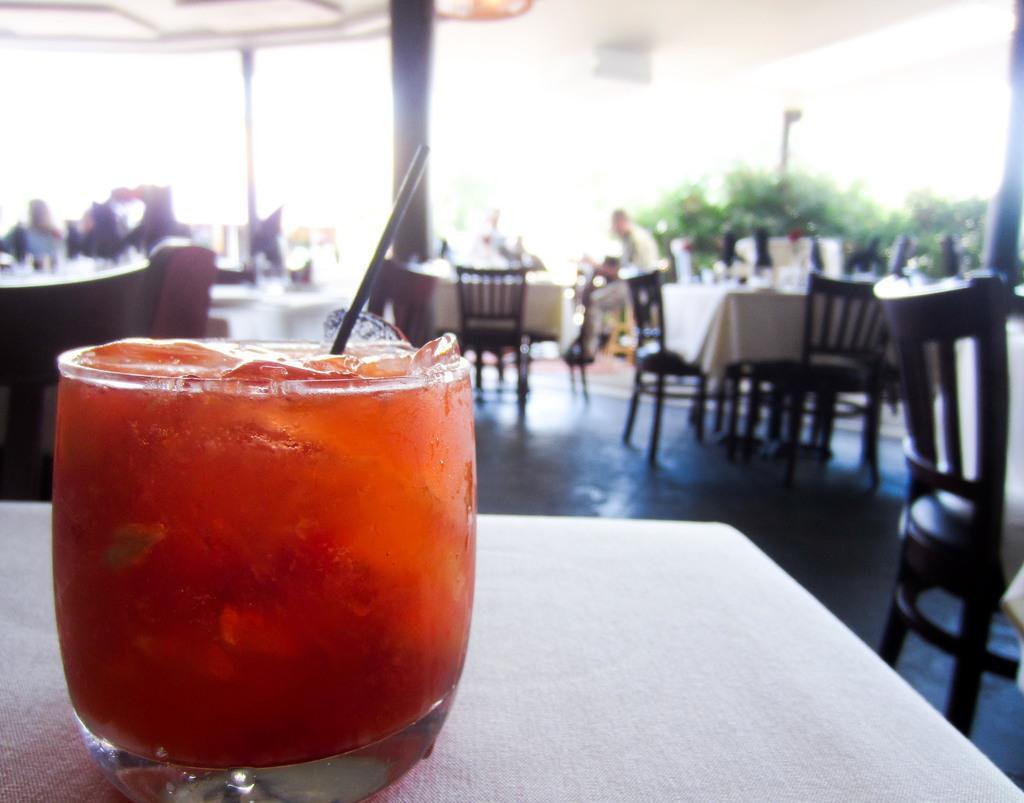What is in the glass that is on the table in the image? There is juice in the glass on the table. What type of furniture is visible in the image? Tables and chairs are visible in the image. Can you describe the people present in the image? There are persons present in the image. What type of natural environment is visible in the image? Trees are visible in the image. What architectural feature can be seen in the image? There is a pillar in the image. Can you hear the duck coughing in the image? There is no duck or coughing sound present in the image. What type of pencil is being used by the persons in the image? There is no pencil visible in the image. 